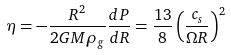<formula> <loc_0><loc_0><loc_500><loc_500>\eta = - \frac { R ^ { 2 } } { 2 G M \rho _ { g } } \frac { d P } { d R } = \frac { 1 3 } { 8 } \left ( \frac { c _ { s } } { \Omega R } \right ) ^ { 2 }</formula> 